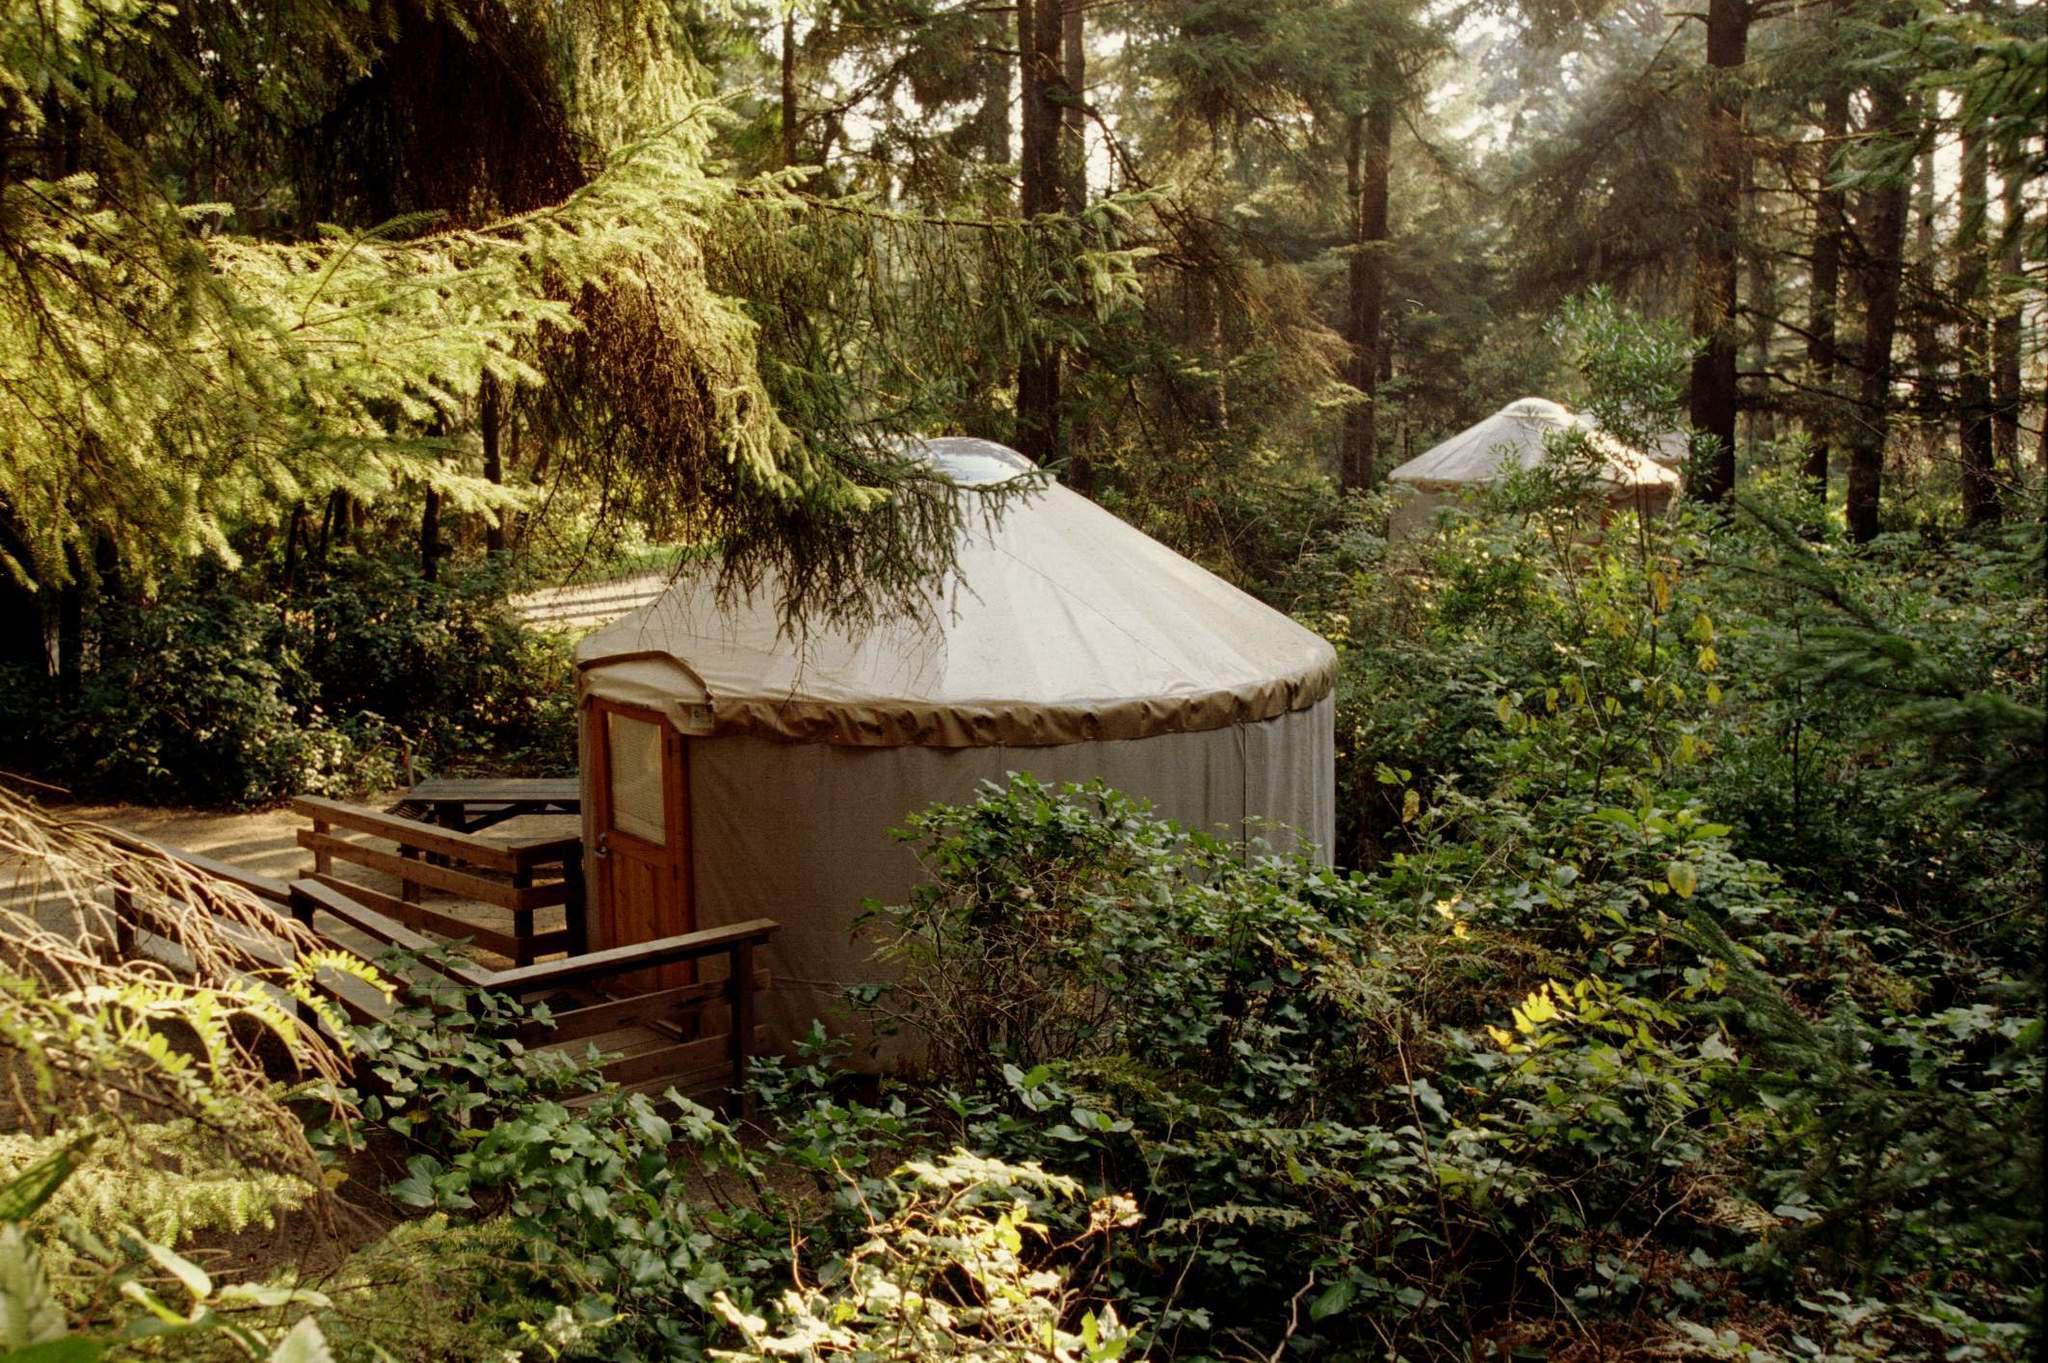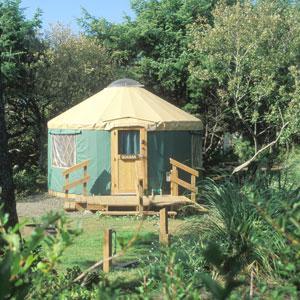The first image is the image on the left, the second image is the image on the right. For the images displayed, is the sentence "At least one round house has a wooden porch area with a roof." factually correct? Answer yes or no. No. The first image is the image on the left, the second image is the image on the right. Evaluate the accuracy of this statement regarding the images: "There is a covered wooden structure to the right of the yurt in the image on the right". Is it true? Answer yes or no. No. 